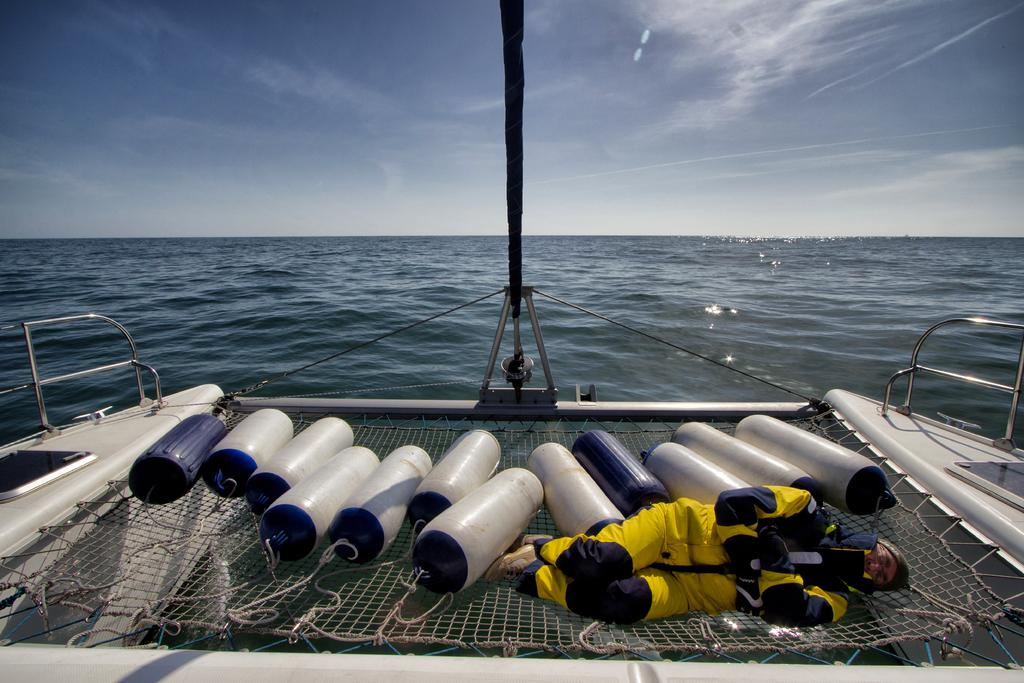What type of natural environment is depicted in the image? There is a sea in the image. What else can be seen in the sky in the image? There is a sky in the image. What is the man doing in the image? There is a man sleeping on a ship in the image. What type of dust can be seen on the ground in the image? There is no dust or ground present in the image; it features a sea and a sky. 